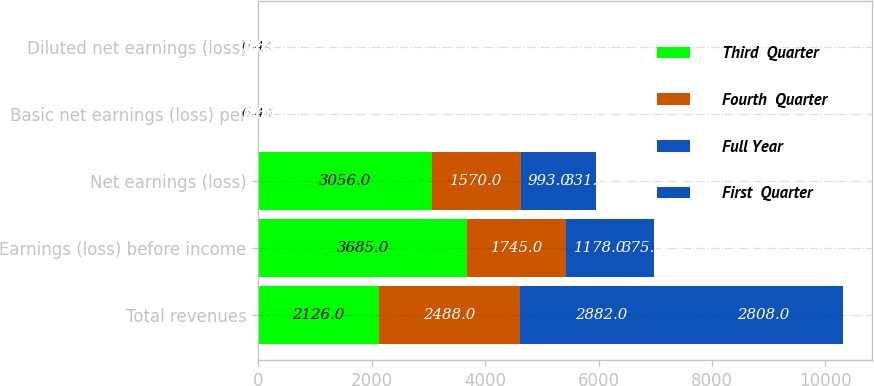<chart> <loc_0><loc_0><loc_500><loc_500><stacked_bar_chart><ecel><fcel>Total revenues<fcel>Earnings (loss) before income<fcel>Net earnings (loss)<fcel>Basic net earnings (loss) per<fcel>Diluted net earnings (loss)<nl><fcel>Third  Quarter<fcel>2126<fcel>3685<fcel>3056<fcel>6.44<fcel>6.44<nl><fcel>Fourth  Quarter<fcel>2488<fcel>1745<fcel>1570<fcel>3.04<fcel>3.04<nl><fcel>Full Year<fcel>2882<fcel>1178<fcel>993<fcel>1.9<fcel>1.89<nl><fcel>First  Quarter<fcel>2808<fcel>375<fcel>331<fcel>0.63<fcel>0.63<nl></chart> 